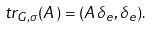Convert formula to latex. <formula><loc_0><loc_0><loc_500><loc_500>\ t r _ { G , \sigma } ( A ) = ( A \delta _ { e } , \delta _ { e } ) .</formula> 